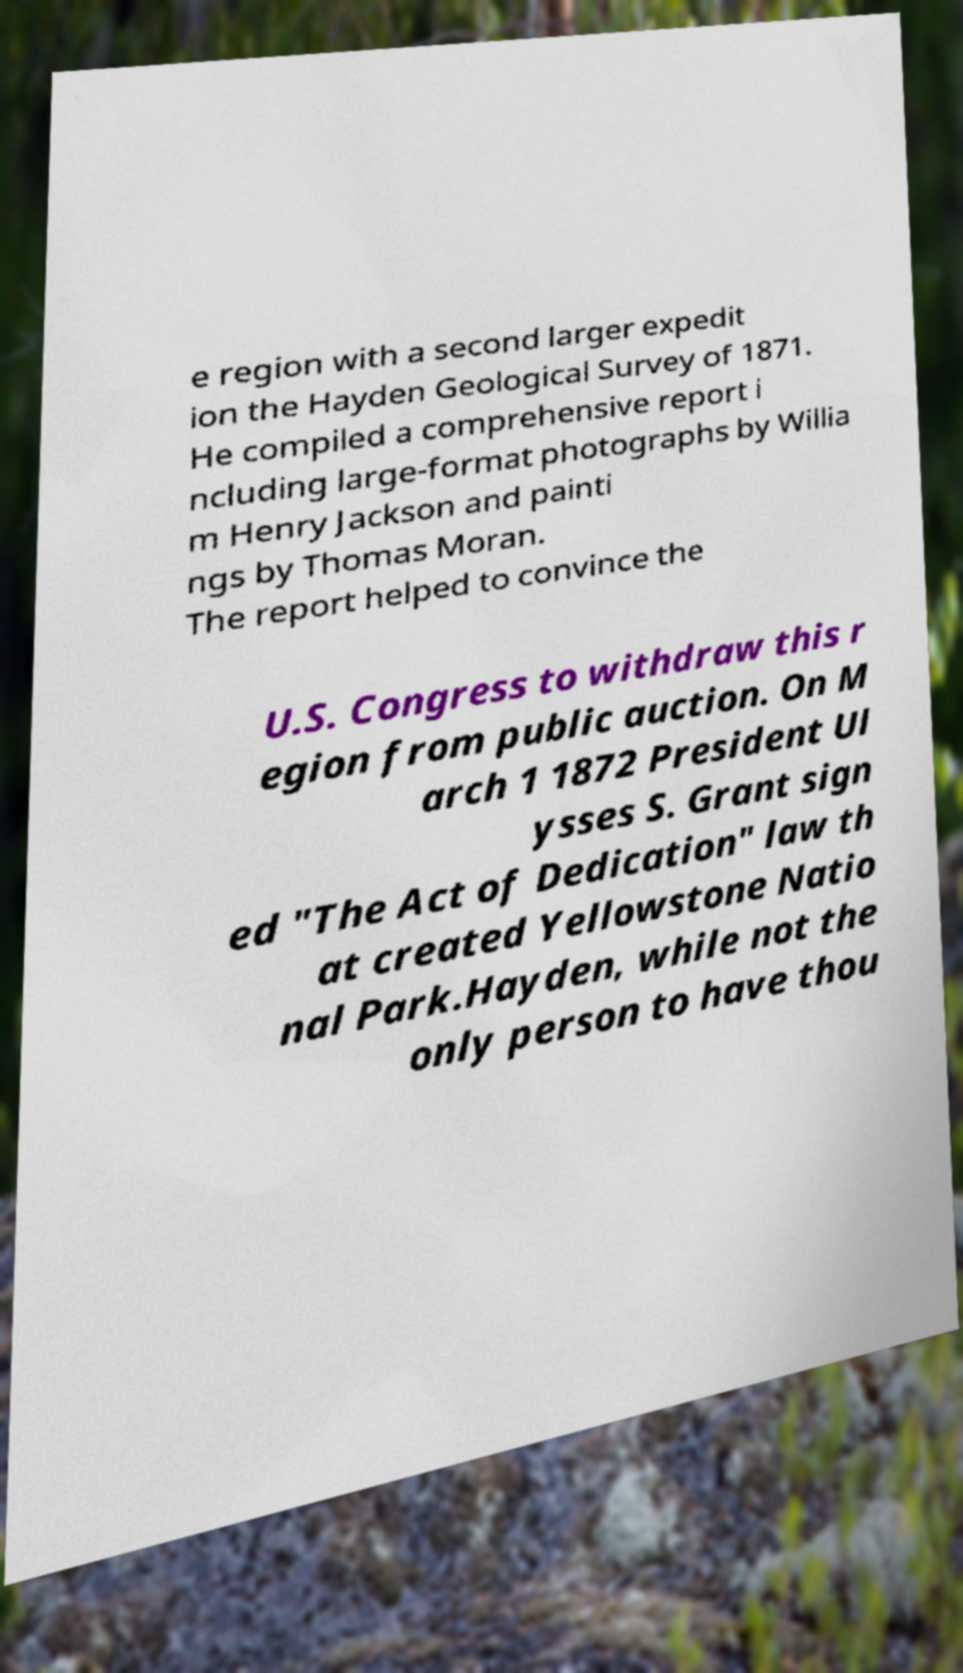Please identify and transcribe the text found in this image. e region with a second larger expedit ion the Hayden Geological Survey of 1871. He compiled a comprehensive report i ncluding large-format photographs by Willia m Henry Jackson and painti ngs by Thomas Moran. The report helped to convince the U.S. Congress to withdraw this r egion from public auction. On M arch 1 1872 President Ul ysses S. Grant sign ed "The Act of Dedication" law th at created Yellowstone Natio nal Park.Hayden, while not the only person to have thou 